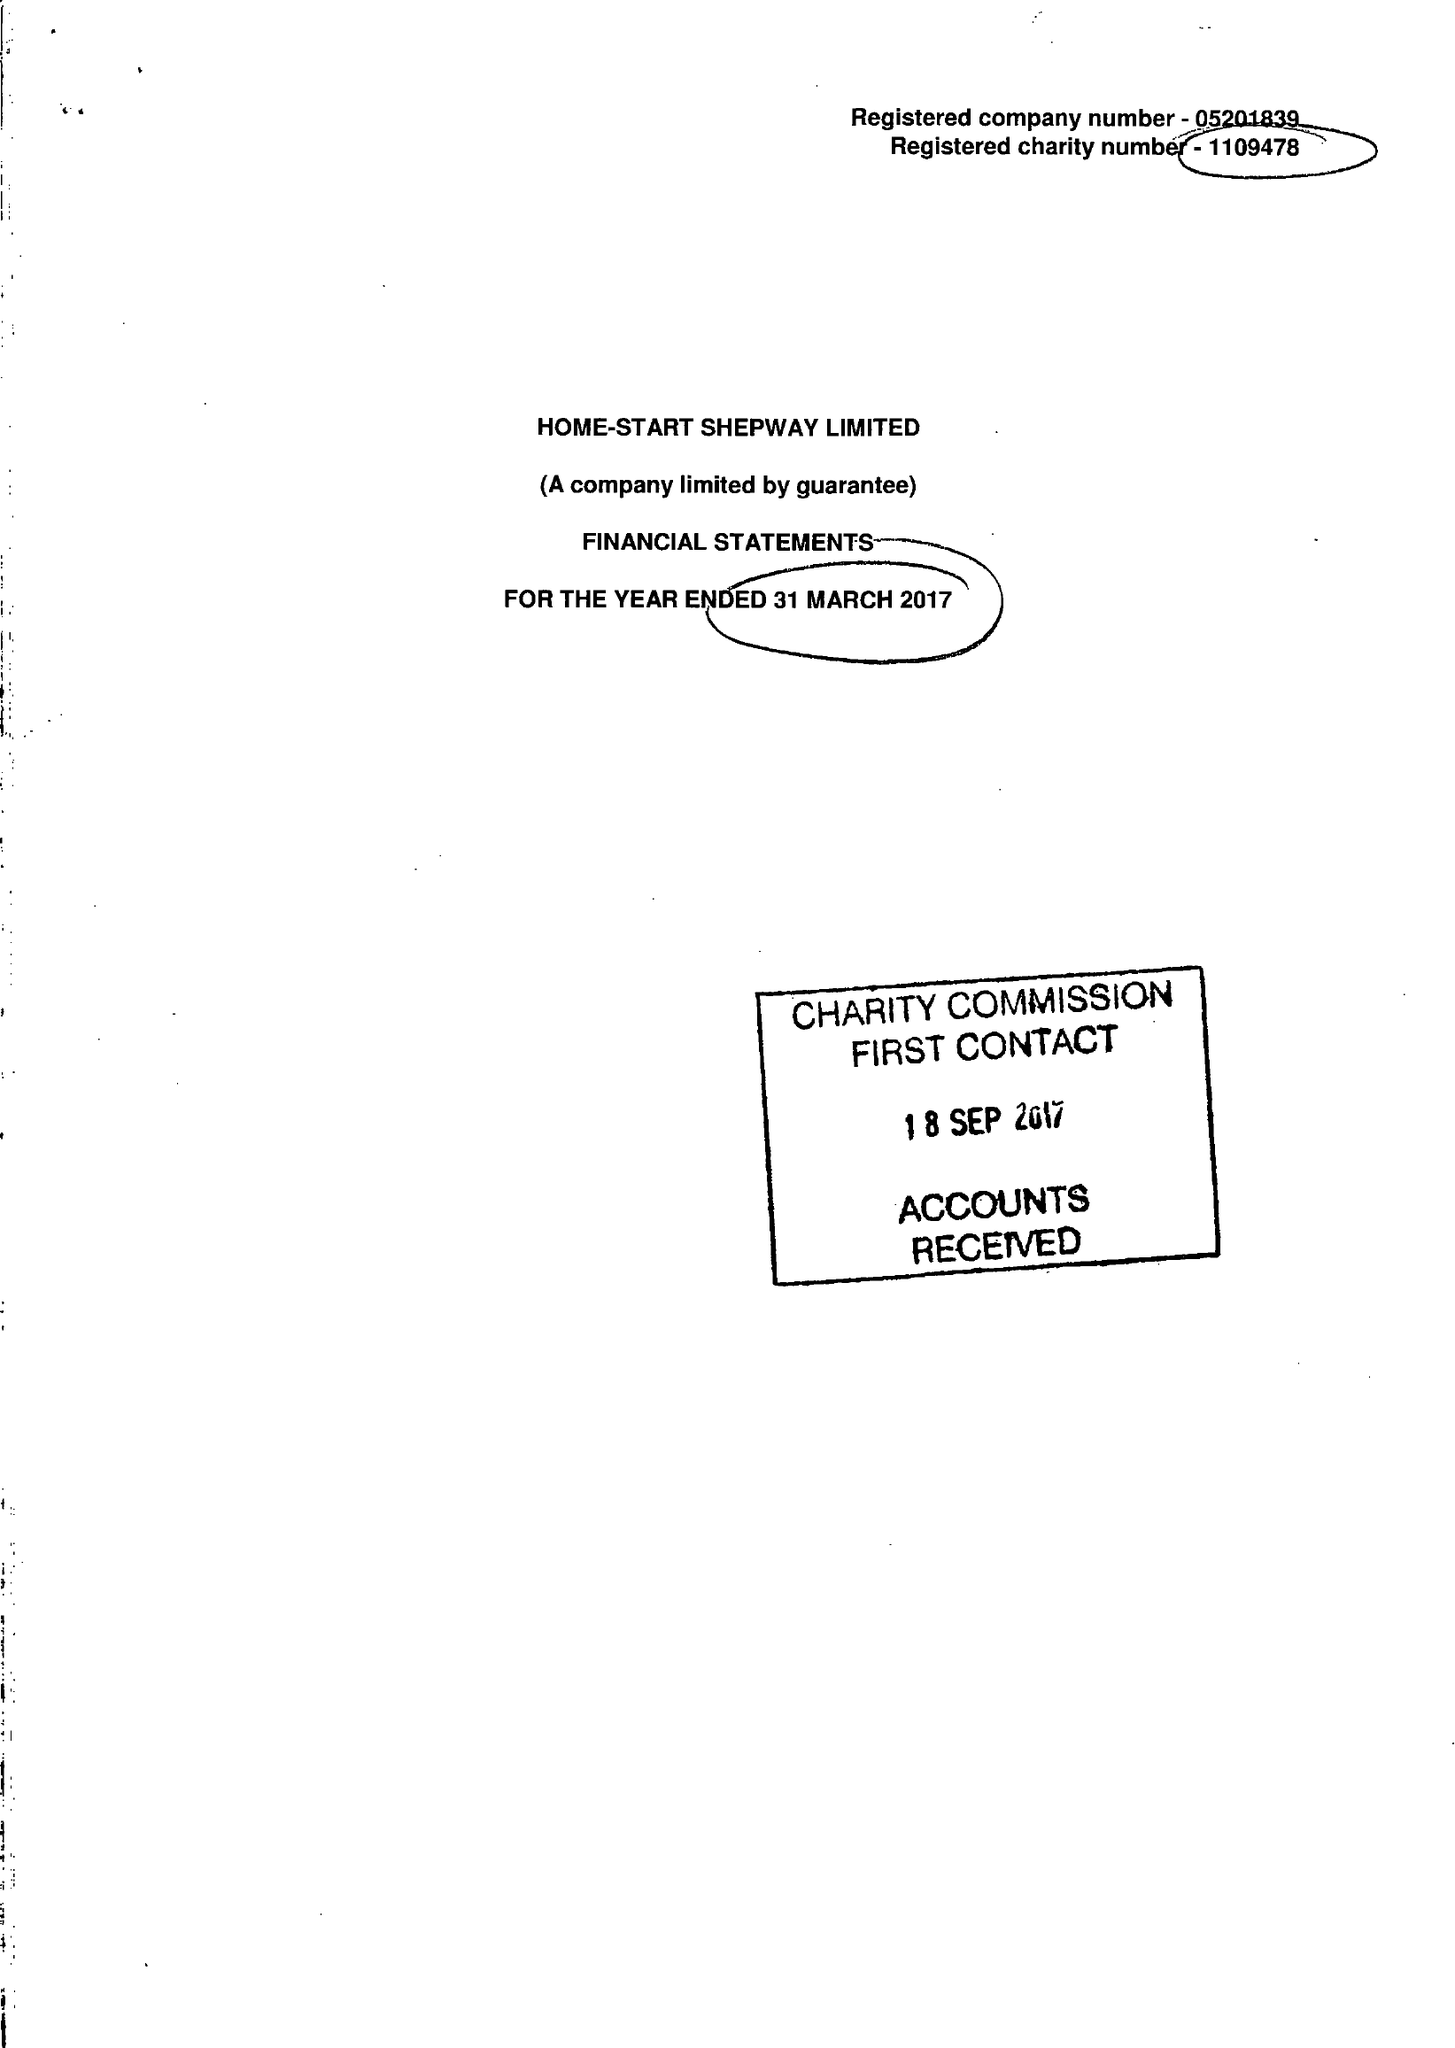What is the value for the spending_annually_in_british_pounds?
Answer the question using a single word or phrase. 260770.00 